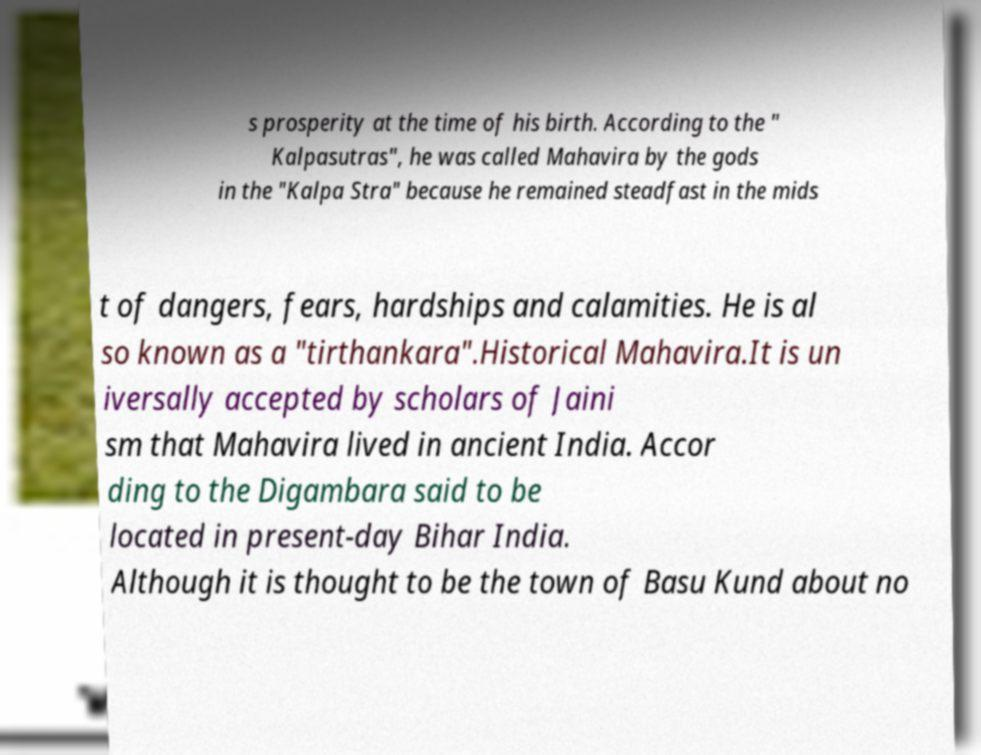Please read and relay the text visible in this image. What does it say? s prosperity at the time of his birth. According to the " Kalpasutras", he was called Mahavira by the gods in the "Kalpa Stra" because he remained steadfast in the mids t of dangers, fears, hardships and calamities. He is al so known as a "tirthankara".Historical Mahavira.It is un iversally accepted by scholars of Jaini sm that Mahavira lived in ancient India. Accor ding to the Digambara said to be located in present-day Bihar India. Although it is thought to be the town of Basu Kund about no 